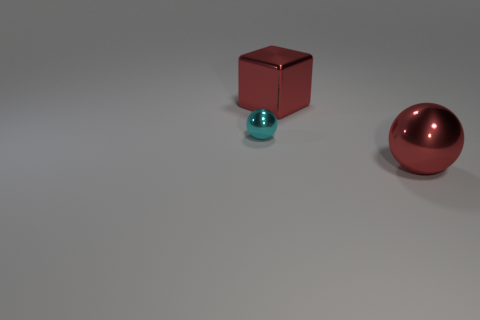Add 1 green matte cylinders. How many objects exist? 4 Subtract all balls. How many objects are left? 1 Subtract all cubes. Subtract all metal cubes. How many objects are left? 1 Add 2 big red cubes. How many big red cubes are left? 3 Add 2 red matte blocks. How many red matte blocks exist? 2 Subtract 0 green blocks. How many objects are left? 3 